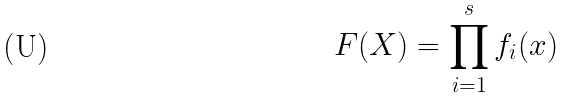Convert formula to latex. <formula><loc_0><loc_0><loc_500><loc_500>F ( X ) = \prod _ { i = 1 } ^ { s } f _ { i } ( x )</formula> 